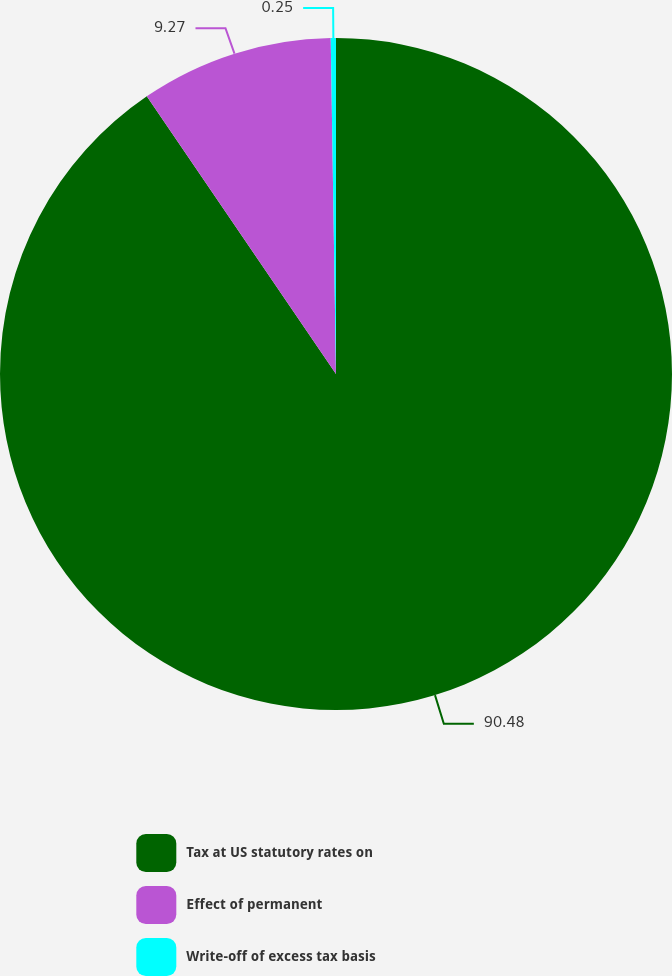<chart> <loc_0><loc_0><loc_500><loc_500><pie_chart><fcel>Tax at US statutory rates on<fcel>Effect of permanent<fcel>Write-off of excess tax basis<nl><fcel>90.48%<fcel>9.27%<fcel>0.25%<nl></chart> 